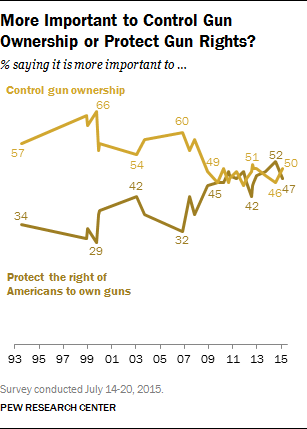What trend does the light brown line show in the graph? The light brown line in the graph shows the trends in public opinion regarding the protection of Americans' rights to own guns. It displays how the percentages have varied from 1993 to 2015, with a general increase in the recent years according to the graph. 